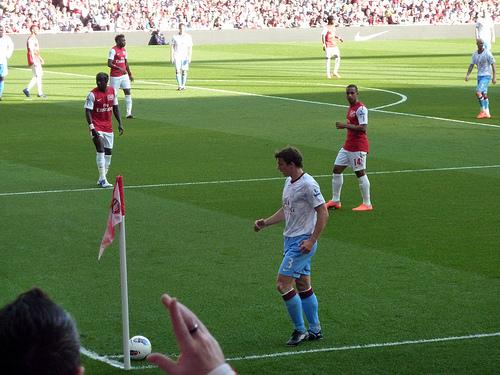Question: who is in the photo?
Choices:
A. A policeman.
B. My father and grandfather.
C. My work colleagues.
D. Players.
Answer with the letter. Answer: D Question: why is there an audience?
Choices:
A. To bring in revenue.
B. To watch the play.
C. To give the marketing people feedback.
D. To watch soccer.
Answer with the letter. Answer: D Question: what are the people doing?
Choices:
A. Eating.
B. Watching a play.
C. Playing soccer.
D. Fighting.
Answer with the letter. Answer: C Question: how is the weather?
Choices:
A. Cloudy.
B. Crisp and clear.
C. Sunny.
D. A storm's coming.
Answer with the letter. Answer: C Question: what are the men wearing on top?
Choices:
A. T-shirts.
B. Hard hats.
C. Polo shirts.
D. Jackets.
Answer with the letter. Answer: A 